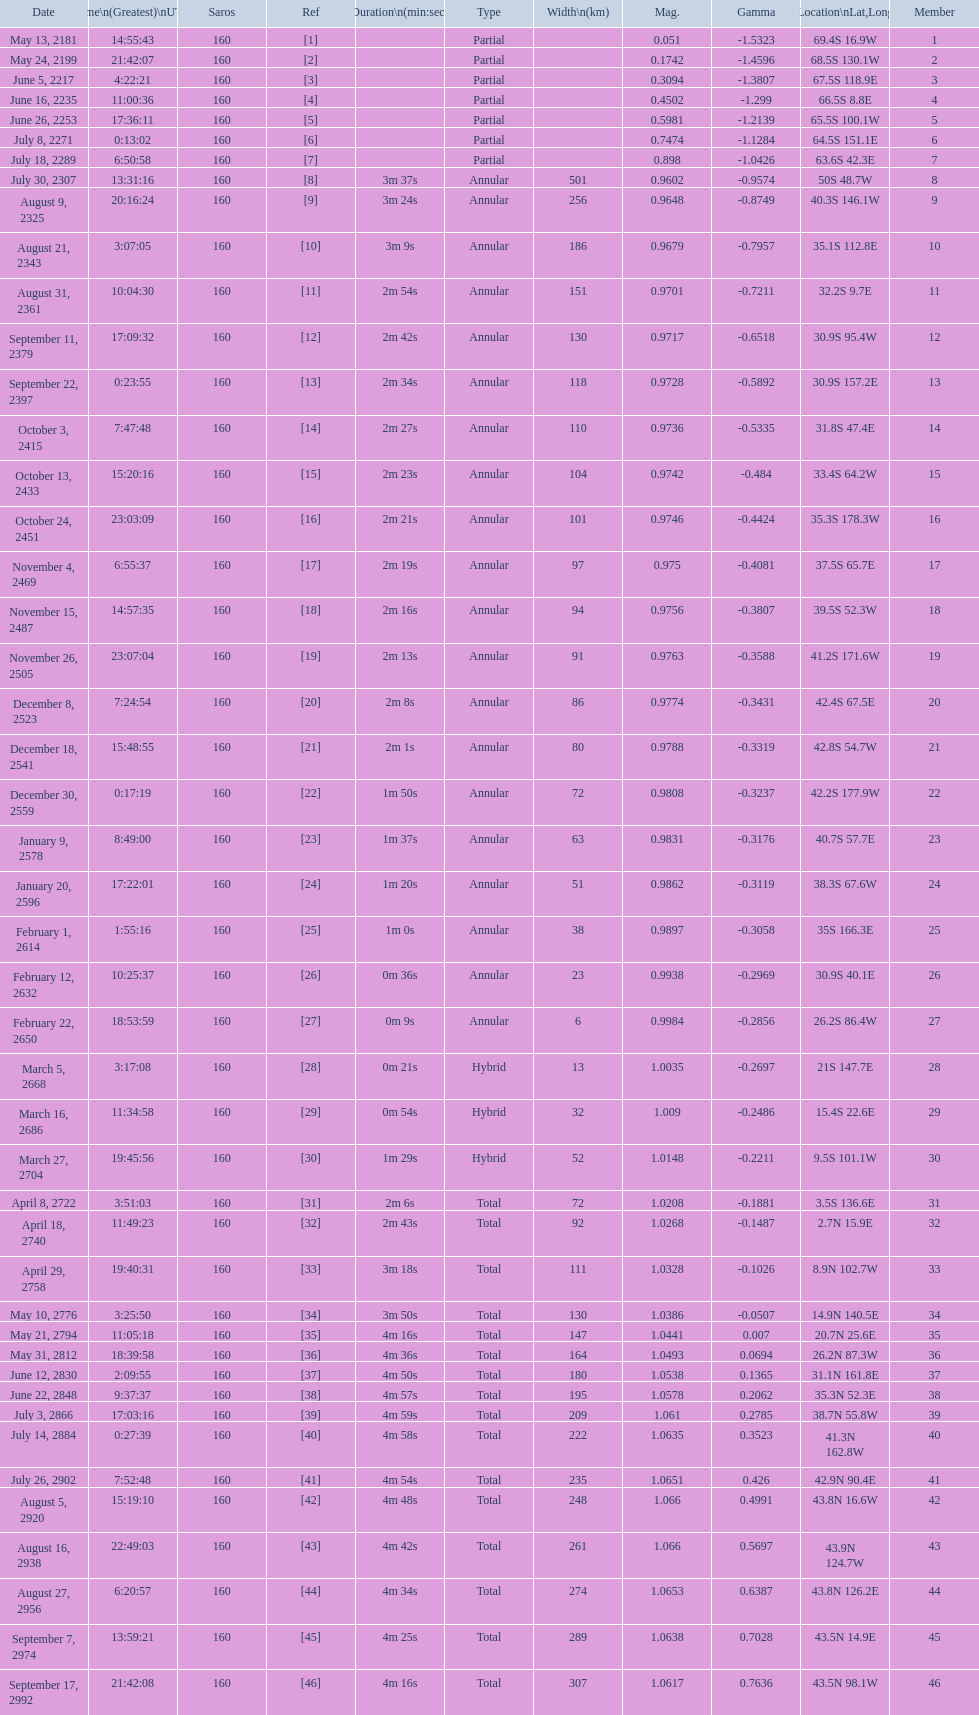When will the next solar saros be after the may 24, 2199 solar saros occurs? June 5, 2217. 